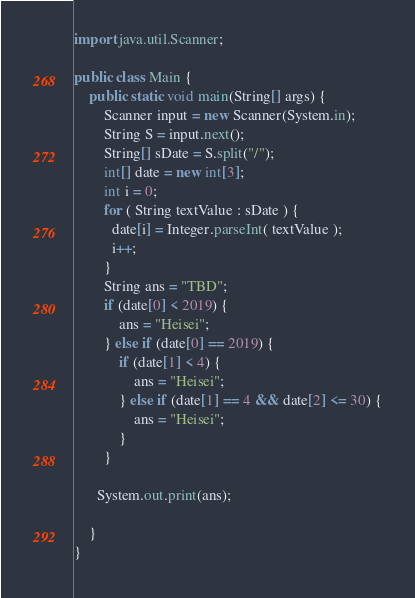Convert code to text. <code><loc_0><loc_0><loc_500><loc_500><_Java_>import java.util.Scanner;

public class Main {
	public static void main(String[] args) {
    	Scanner input = new Scanner(System.in);
      	String S = input.next();
      	String[] sDate = S.split("/");
      	int[] date = new int[3];
      	int i = 0;
        for ( String textValue : sDate ) {
          date[i] = Integer.parseInt( textValue ); 
          i++; 
        } 
      	String ans = "TBD";
      	if (date[0] < 2019) {
        	ans = "Heisei";
        } else if (date[0] == 2019) {
        	if (date[1] < 4) {
            	ans = "Heisei";
            } else if (date[1] == 4 && date[2] <= 30) {
            	ans = "Heisei";
            }
        }
      
      System.out.print(ans);

    }
}
</code> 